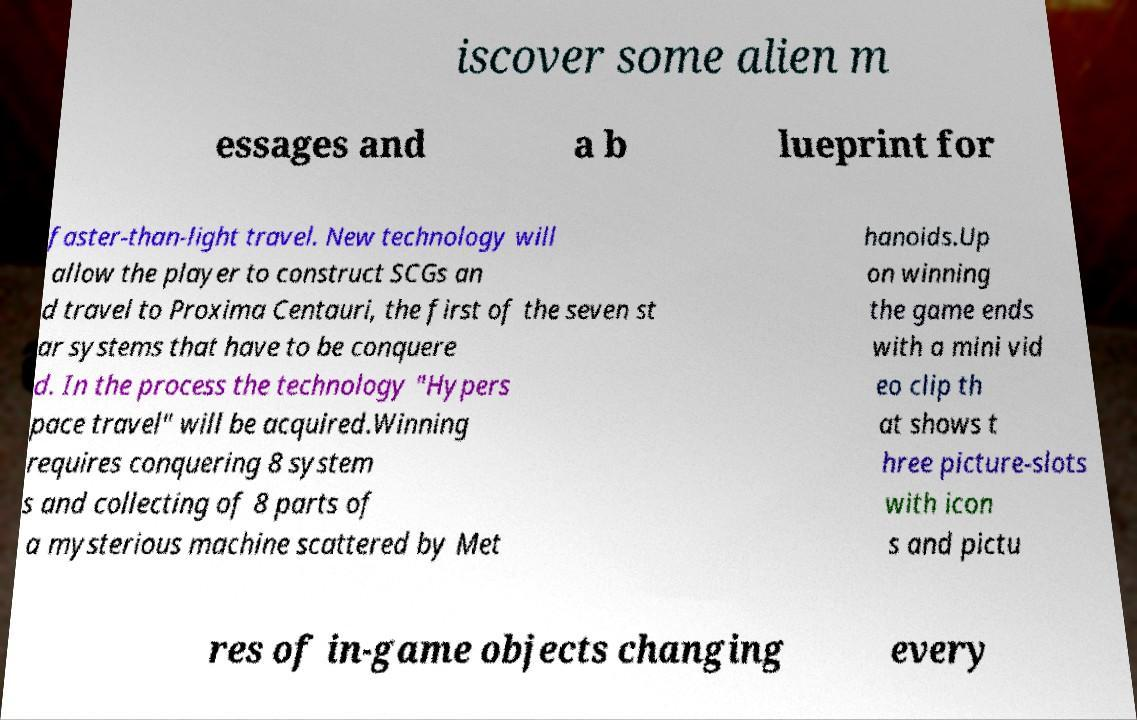Could you assist in decoding the text presented in this image and type it out clearly? iscover some alien m essages and a b lueprint for faster-than-light travel. New technology will allow the player to construct SCGs an d travel to Proxima Centauri, the first of the seven st ar systems that have to be conquere d. In the process the technology "Hypers pace travel" will be acquired.Winning requires conquering 8 system s and collecting of 8 parts of a mysterious machine scattered by Met hanoids.Up on winning the game ends with a mini vid eo clip th at shows t hree picture-slots with icon s and pictu res of in-game objects changing every 